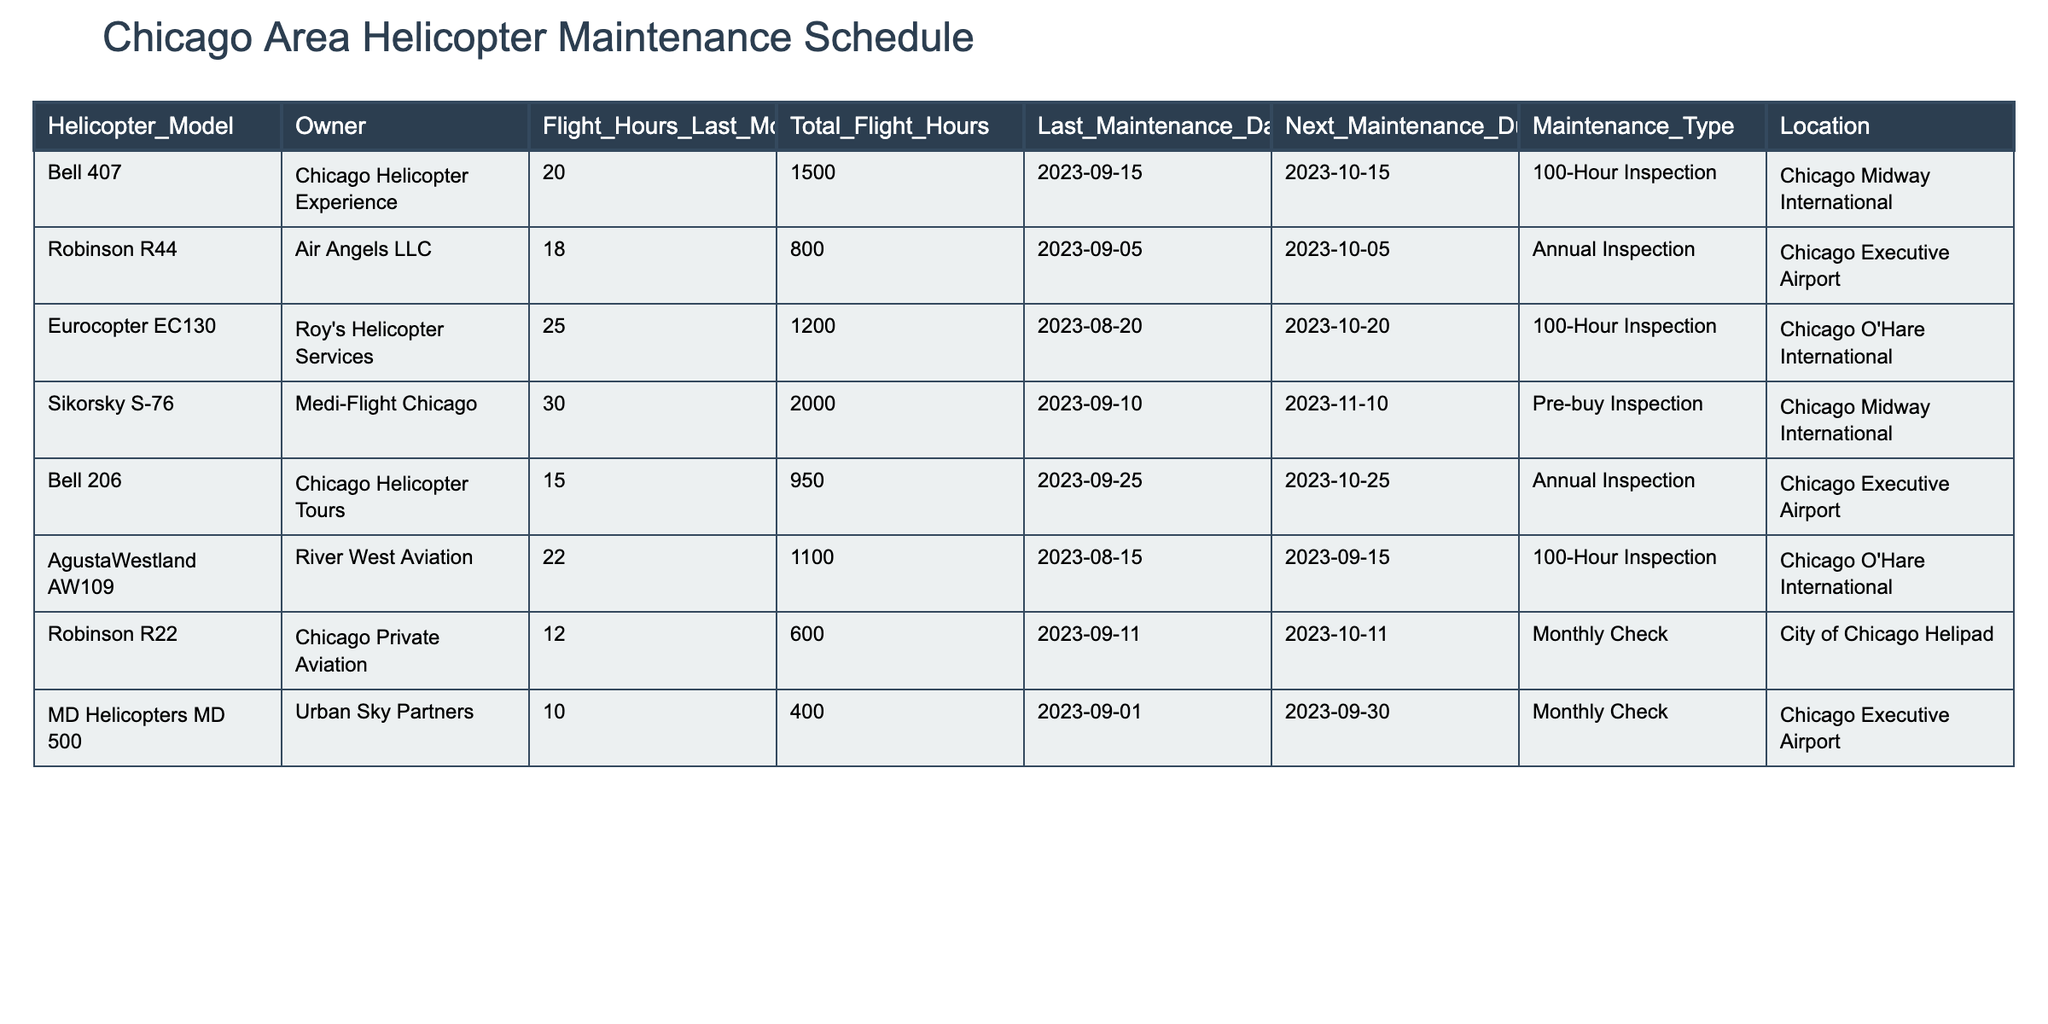What is the total flight hours of the Bell 407? The table lists the flight hours for the Bell 407 as 1500.
Answer: 1500 When is the next maintenance due for the Robinson R44? The table indicates that the Robinson R44's next maintenance is due on 2023-10-05.
Answer: 2023-10-05 How many flight hours did the Sikorsky S-76 accumulate last month? The Sikorsky S-76 had 30 flight hours last month, as stated in the table.
Answer: 30 Which helicopter had the most flight hours last month? By comparing the values in the "Flight_Hours_Last_Month" column, the Sikorsky S-76 had the highest at 30 hours.
Answer: Sikorsky S-76 What maintenance type is due for the Bell 206? The table shows that the Bell 206 is due for an Annual Inspection.
Answer: Annual Inspection Is the next maintenance for the AgustaWestland AW109 due before October 1, 2023? Looking at the "Next_Maintenance_Due" column, the next maintenance for the AgustaWestland AW109 is due on 2023-09-15, which is before October 1.
Answer: Yes Which helicopter has the fewest total flight hours? By reviewing the "Total_Flight_Hours" column, the Robinson R22 has the fewest with 600 total flight hours.
Answer: Robinson R22 What is the average flight hours last month for the helicopters listed? Adding the flight hours last month (20 + 18 + 25 + 30 + 15 + 22 + 12 + 10) gives 152, and dividing by 8 (the number of helicopters) results in an average of 19.
Answer: 19 How many helicopters are due for a 100-hour inspection in October? The table indicates that the Bell 407 and Eurocopter EC130 are both due for a 100-Hour Inspection in October, totaling 2 helicopters.
Answer: 2 Which helicopter's next maintenance is due at the Chicago O'Hare International? The Eurocopter EC130 and AgustaWestland AW109 both have their next maintenance due at Chicago O'Hare International.
Answer: Eurocopter EC130, AgustaWestland AW109 What was the flight hour difference between the helicopter with the most hours and the one with the least last month? Sikorsky S-76 had the most at 30 hours while Robinson R22 had the least at 12 hours. The difference is 30 - 12 = 18.
Answer: 18 Does any helicopter owned by Air Angels LLC require maintenance in the next week? The Robinson R44, owned by Air Angels LLC, is due for maintenance on 2023-10-05, which is within the next week from now.
Answer: Yes 